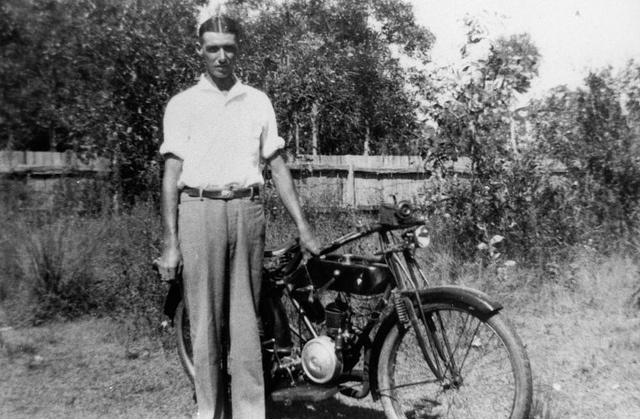Describe the objects in this image and their specific colors. I can see motorcycle in black, darkgray, gray, and lightgray tones and people in black, darkgray, lightgray, and gray tones in this image. 